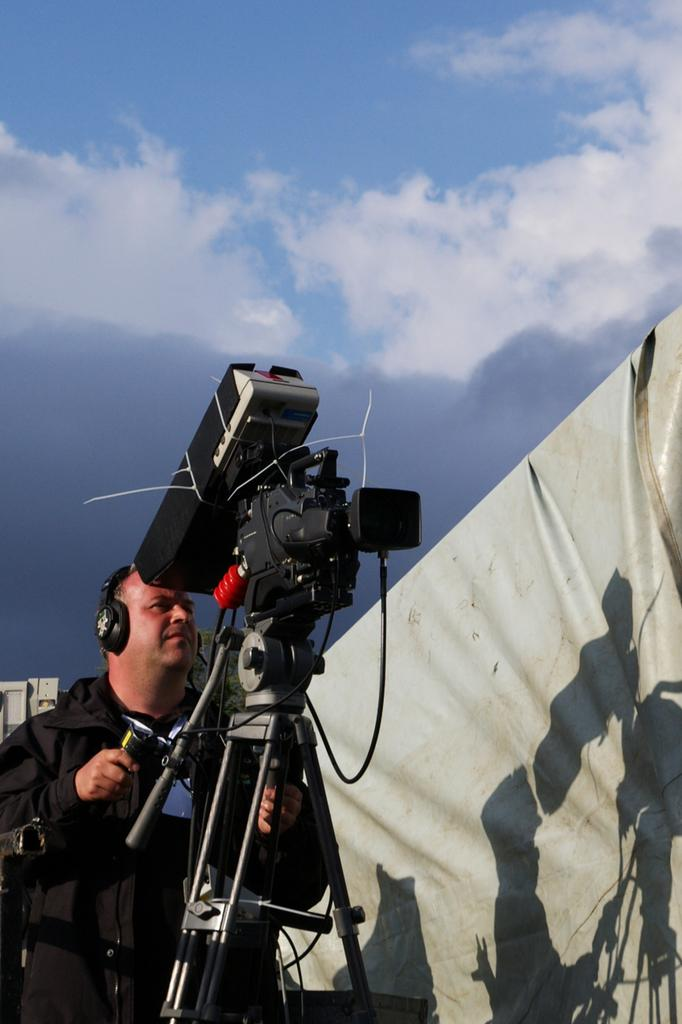What is the main subject of the image? There is a person standing in the image. What is the person wearing? The person is wearing a black dress. What object is in front of the person? There is a camera in front of the person. What can be seen in the background of the image? The background of the image includes a blue and white sky. What type of polish is the person applying to their nails in the image? There is no indication in the image that the person is applying polish to their nails, as they are wearing a black dress and standing in front of a camera. --- Facts: 1. There is a car in the image. 2. The car is red. 3. The car has four wheels. 4. There is a road in the image. 5. The road is paved. Absurd Topics: parrot, sand, dance Conversation: What is the main subject of the image? There is a car in the image. What color is the car? The car is red. How many wheels does the car have? The car has four wheels. What type of surface is the car on? There is a road in the image, and it is paved. Reasoning: Let's think step by step in order to produce the conversation. We start by identifying the main subject of the image, which is the car. Then, we describe the car's color, noting that it is red. Next, we mention the number of wheels the car has, which is four. Finally, we describe the surface the car is on, which is a paved road. Absurd Question/Answer: Can you see a parrot dancing on the sand in the image? There is no parrot or sand present in the image; it features a red car on a paved road. 